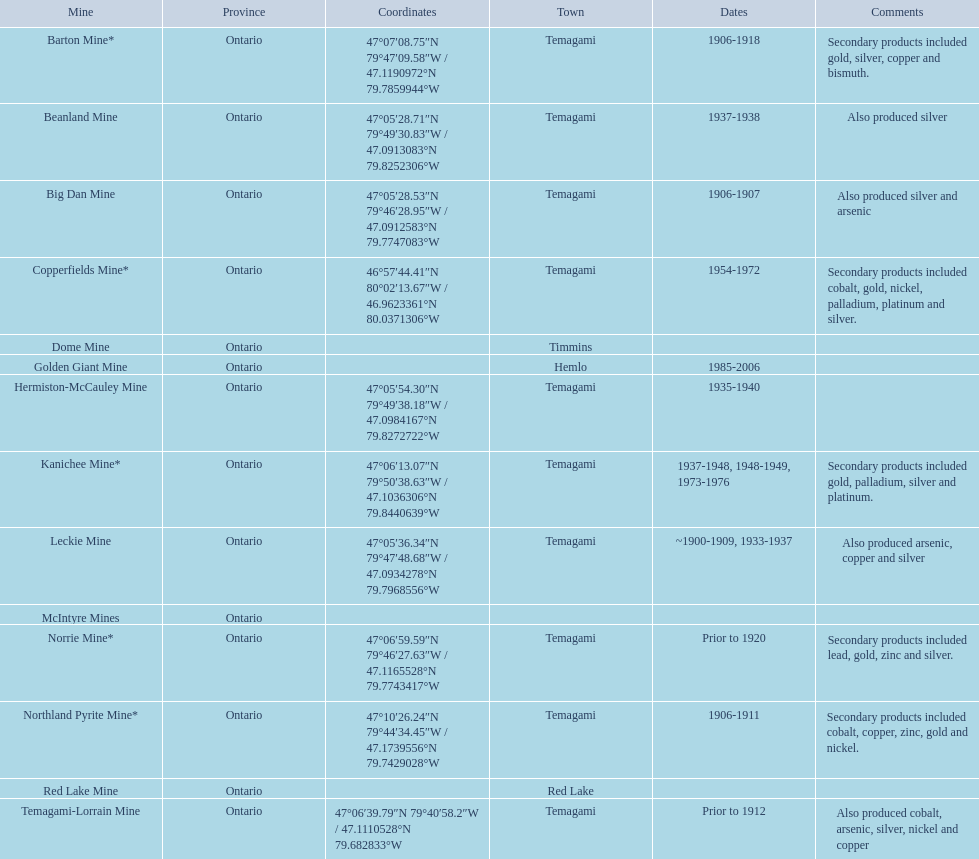What dates was the golden giant mine open? 1985-2006. What dates was the beanland mine open? 1937-1938. Of those mines, which was open longer? Golden Giant Mine. 